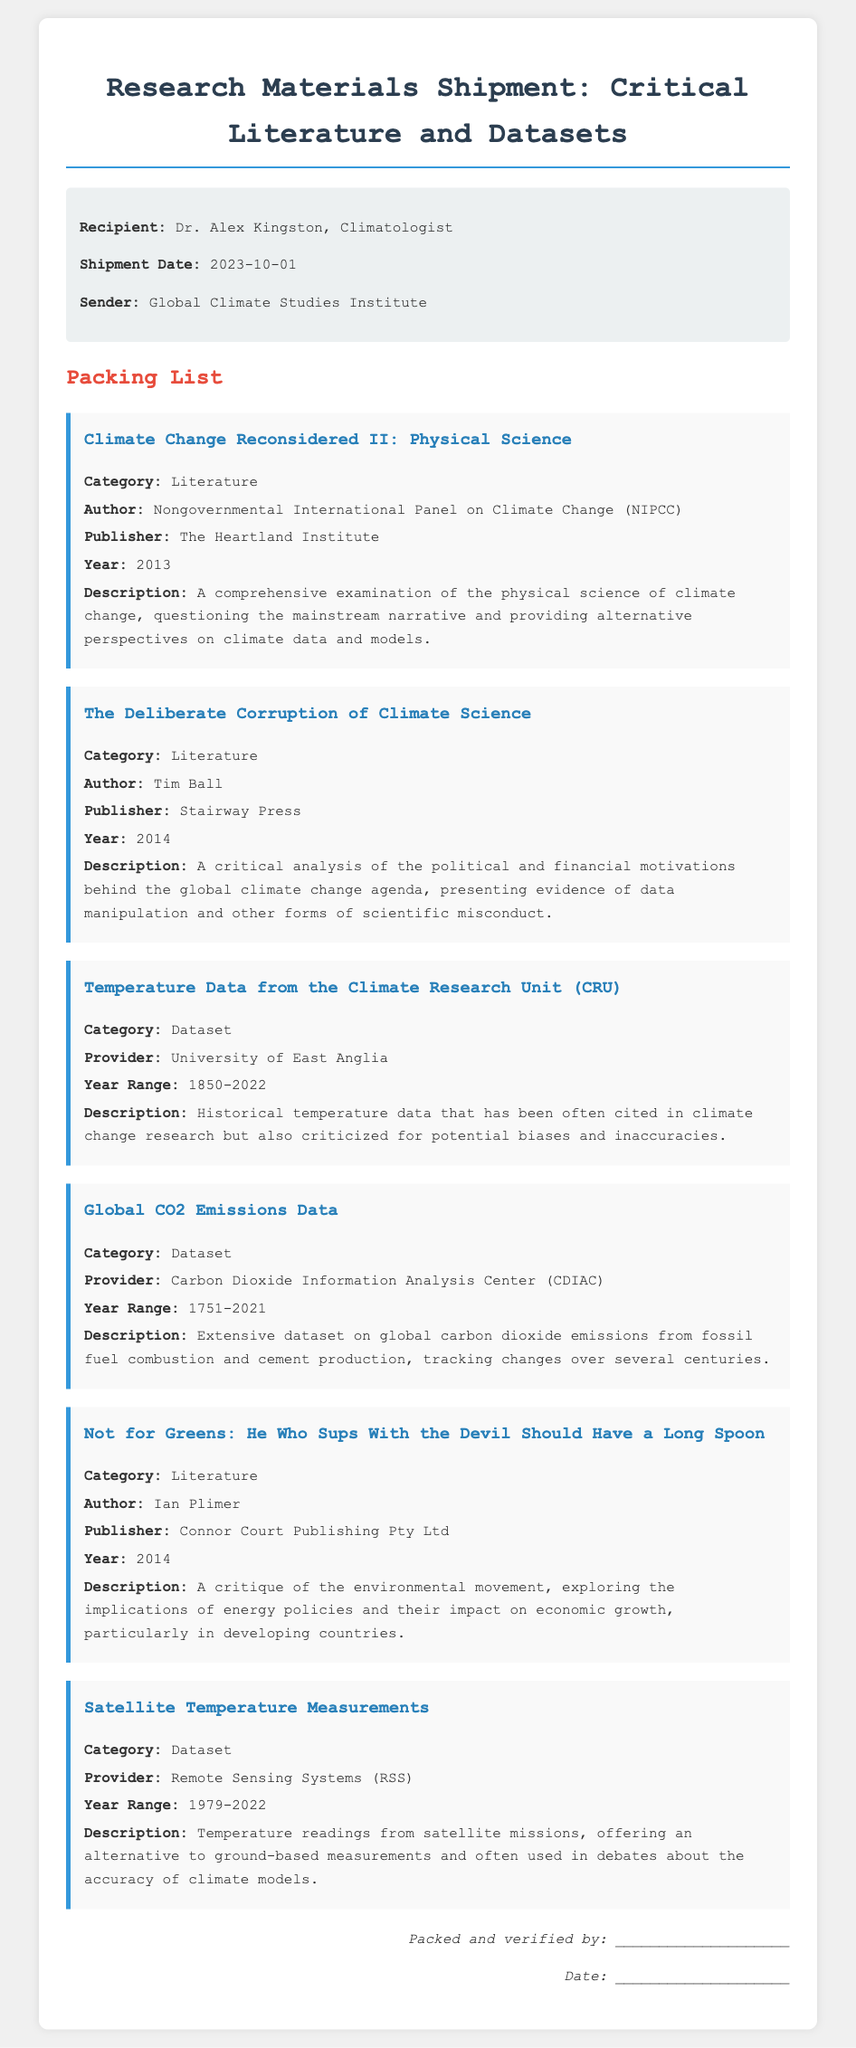What is the name of the recipient? The recipient's name is provided in the meta-info section of the document.
Answer: Dr. Alex Kingston What is the shipment date? The shipment date is mentioned in the meta-info section.
Answer: 2023-10-01 Who is the author of "Climate Change Reconsidered II: Physical Science"? The author is listed under the item describing the literature.
Answer: Nongovernmental International Panel on Climate Change (NIPCC) What is the year range for the Global CO2 Emissions Data? The year range is indicated in the description of the dataset.
Answer: 1751-2021 What publisher is associated with "The Deliberate Corruption of Climate Science"? The publisher of this literature is mentioned in the item description.
Answer: Stairway Press Which dataset covers temperature readings from satellite missions? The description specifies the category for this dataset within the document.
Answer: Satellite Temperature Measurements Why is "Temperature Data from the Climate Research Unit (CRU)" criticized? The description states that the data has been criticized for potential biases and inaccuracies.
Answer: Potential biases and inaccuracies What type of document is this? The structure and content indicate it is focused on the packing list of research materials.
Answer: Packing list 